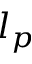Convert formula to latex. <formula><loc_0><loc_0><loc_500><loc_500>l _ { p }</formula> 